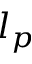Convert formula to latex. <formula><loc_0><loc_0><loc_500><loc_500>l _ { p }</formula> 